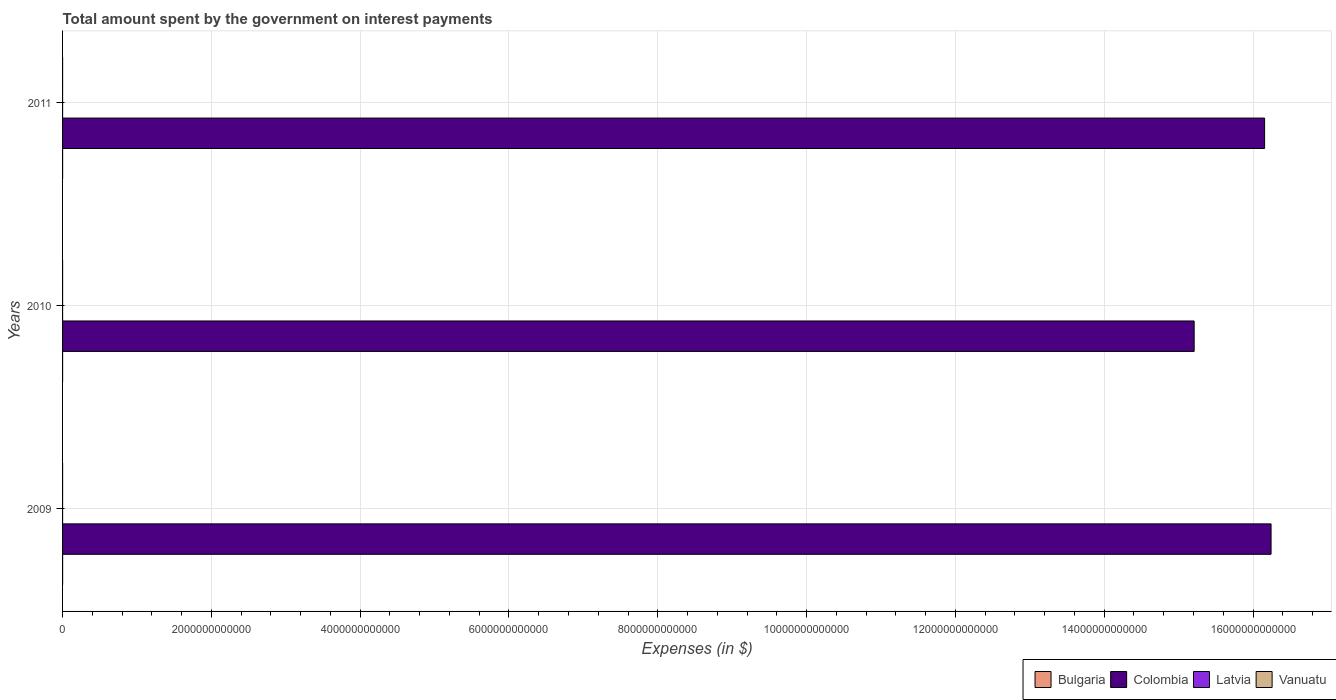Are the number of bars per tick equal to the number of legend labels?
Offer a very short reply. Yes. How many bars are there on the 1st tick from the top?
Keep it short and to the point. 4. How many bars are there on the 3rd tick from the bottom?
Provide a short and direct response. 4. What is the label of the 3rd group of bars from the top?
Ensure brevity in your answer.  2009. What is the amount spent on interest payments by the government in Vanuatu in 2010?
Offer a terse response. 3.34e+08. Across all years, what is the maximum amount spent on interest payments by the government in Latvia?
Offer a terse response. 1.91e+08. Across all years, what is the minimum amount spent on interest payments by the government in Vanuatu?
Provide a succinct answer. 3.18e+08. In which year was the amount spent on interest payments by the government in Bulgaria maximum?
Give a very brief answer. 2011. What is the total amount spent on interest payments by the government in Colombia in the graph?
Your response must be concise. 4.76e+13. What is the difference between the amount spent on interest payments by the government in Bulgaria in 2009 and that in 2010?
Provide a short and direct response. 4.27e+07. What is the difference between the amount spent on interest payments by the government in Latvia in 2010 and the amount spent on interest payments by the government in Colombia in 2011?
Offer a terse response. -1.62e+13. What is the average amount spent on interest payments by the government in Bulgaria per year?
Offer a very short reply. 4.92e+08. In the year 2009, what is the difference between the amount spent on interest payments by the government in Colombia and amount spent on interest payments by the government in Bulgaria?
Offer a terse response. 1.62e+13. What is the ratio of the amount spent on interest payments by the government in Bulgaria in 2010 to that in 2011?
Your answer should be very brief. 0.89. What is the difference between the highest and the second highest amount spent on interest payments by the government in Latvia?
Provide a short and direct response. 2.07e+07. What is the difference between the highest and the lowest amount spent on interest payments by the government in Bulgaria?
Give a very brief answer. 5.47e+07. Is the sum of the amount spent on interest payments by the government in Colombia in 2010 and 2011 greater than the maximum amount spent on interest payments by the government in Bulgaria across all years?
Keep it short and to the point. Yes. What does the 3rd bar from the top in 2009 represents?
Ensure brevity in your answer.  Colombia. What does the 2nd bar from the bottom in 2010 represents?
Your answer should be compact. Colombia. Are all the bars in the graph horizontal?
Ensure brevity in your answer.  Yes. What is the difference between two consecutive major ticks on the X-axis?
Offer a terse response. 2.00e+12. Are the values on the major ticks of X-axis written in scientific E-notation?
Keep it short and to the point. No. Does the graph contain any zero values?
Make the answer very short. No. Where does the legend appear in the graph?
Give a very brief answer. Bottom right. How are the legend labels stacked?
Your answer should be compact. Horizontal. What is the title of the graph?
Make the answer very short. Total amount spent by the government on interest payments. What is the label or title of the X-axis?
Provide a succinct answer. Expenses (in $). What is the label or title of the Y-axis?
Your answer should be compact. Years. What is the Expenses (in $) in Bulgaria in 2009?
Ensure brevity in your answer.  5.03e+08. What is the Expenses (in $) in Colombia in 2009?
Your response must be concise. 1.62e+13. What is the Expenses (in $) of Latvia in 2009?
Make the answer very short. 1.44e+08. What is the Expenses (in $) in Vanuatu in 2009?
Provide a succinct answer. 3.18e+08. What is the Expenses (in $) in Bulgaria in 2010?
Your answer should be compact. 4.60e+08. What is the Expenses (in $) in Colombia in 2010?
Ensure brevity in your answer.  1.52e+13. What is the Expenses (in $) of Latvia in 2010?
Give a very brief answer. 1.70e+08. What is the Expenses (in $) in Vanuatu in 2010?
Your answer should be compact. 3.34e+08. What is the Expenses (in $) of Bulgaria in 2011?
Offer a very short reply. 5.15e+08. What is the Expenses (in $) of Colombia in 2011?
Your answer should be compact. 1.62e+13. What is the Expenses (in $) of Latvia in 2011?
Ensure brevity in your answer.  1.91e+08. What is the Expenses (in $) of Vanuatu in 2011?
Your answer should be very brief. 4.68e+08. Across all years, what is the maximum Expenses (in $) in Bulgaria?
Keep it short and to the point. 5.15e+08. Across all years, what is the maximum Expenses (in $) of Colombia?
Your response must be concise. 1.62e+13. Across all years, what is the maximum Expenses (in $) of Latvia?
Offer a very short reply. 1.91e+08. Across all years, what is the maximum Expenses (in $) in Vanuatu?
Provide a short and direct response. 4.68e+08. Across all years, what is the minimum Expenses (in $) of Bulgaria?
Your answer should be very brief. 4.60e+08. Across all years, what is the minimum Expenses (in $) in Colombia?
Offer a terse response. 1.52e+13. Across all years, what is the minimum Expenses (in $) of Latvia?
Keep it short and to the point. 1.44e+08. Across all years, what is the minimum Expenses (in $) in Vanuatu?
Your answer should be very brief. 3.18e+08. What is the total Expenses (in $) in Bulgaria in the graph?
Offer a very short reply. 1.48e+09. What is the total Expenses (in $) in Colombia in the graph?
Provide a short and direct response. 4.76e+13. What is the total Expenses (in $) of Latvia in the graph?
Give a very brief answer. 5.05e+08. What is the total Expenses (in $) of Vanuatu in the graph?
Offer a terse response. 1.12e+09. What is the difference between the Expenses (in $) of Bulgaria in 2009 and that in 2010?
Your answer should be compact. 4.27e+07. What is the difference between the Expenses (in $) of Colombia in 2009 and that in 2010?
Offer a very short reply. 1.03e+12. What is the difference between the Expenses (in $) in Latvia in 2009 and that in 2010?
Your answer should be very brief. -2.62e+07. What is the difference between the Expenses (in $) of Vanuatu in 2009 and that in 2010?
Give a very brief answer. -1.57e+07. What is the difference between the Expenses (in $) of Bulgaria in 2009 and that in 2011?
Keep it short and to the point. -1.20e+07. What is the difference between the Expenses (in $) in Colombia in 2009 and that in 2011?
Provide a short and direct response. 8.67e+1. What is the difference between the Expenses (in $) in Latvia in 2009 and that in 2011?
Your response must be concise. -4.69e+07. What is the difference between the Expenses (in $) of Vanuatu in 2009 and that in 2011?
Your answer should be very brief. -1.50e+08. What is the difference between the Expenses (in $) of Bulgaria in 2010 and that in 2011?
Offer a terse response. -5.47e+07. What is the difference between the Expenses (in $) of Colombia in 2010 and that in 2011?
Keep it short and to the point. -9.47e+11. What is the difference between the Expenses (in $) of Latvia in 2010 and that in 2011?
Provide a short and direct response. -2.07e+07. What is the difference between the Expenses (in $) of Vanuatu in 2010 and that in 2011?
Offer a terse response. -1.34e+08. What is the difference between the Expenses (in $) in Bulgaria in 2009 and the Expenses (in $) in Colombia in 2010?
Keep it short and to the point. -1.52e+13. What is the difference between the Expenses (in $) of Bulgaria in 2009 and the Expenses (in $) of Latvia in 2010?
Offer a very short reply. 3.32e+08. What is the difference between the Expenses (in $) of Bulgaria in 2009 and the Expenses (in $) of Vanuatu in 2010?
Your answer should be compact. 1.69e+08. What is the difference between the Expenses (in $) of Colombia in 2009 and the Expenses (in $) of Latvia in 2010?
Your response must be concise. 1.62e+13. What is the difference between the Expenses (in $) in Colombia in 2009 and the Expenses (in $) in Vanuatu in 2010?
Provide a succinct answer. 1.62e+13. What is the difference between the Expenses (in $) of Latvia in 2009 and the Expenses (in $) of Vanuatu in 2010?
Provide a succinct answer. -1.89e+08. What is the difference between the Expenses (in $) of Bulgaria in 2009 and the Expenses (in $) of Colombia in 2011?
Your answer should be very brief. -1.62e+13. What is the difference between the Expenses (in $) in Bulgaria in 2009 and the Expenses (in $) in Latvia in 2011?
Your response must be concise. 3.12e+08. What is the difference between the Expenses (in $) in Bulgaria in 2009 and the Expenses (in $) in Vanuatu in 2011?
Your response must be concise. 3.51e+07. What is the difference between the Expenses (in $) of Colombia in 2009 and the Expenses (in $) of Latvia in 2011?
Offer a terse response. 1.62e+13. What is the difference between the Expenses (in $) in Colombia in 2009 and the Expenses (in $) in Vanuatu in 2011?
Your response must be concise. 1.62e+13. What is the difference between the Expenses (in $) in Latvia in 2009 and the Expenses (in $) in Vanuatu in 2011?
Your answer should be very brief. -3.23e+08. What is the difference between the Expenses (in $) in Bulgaria in 2010 and the Expenses (in $) in Colombia in 2011?
Make the answer very short. -1.62e+13. What is the difference between the Expenses (in $) of Bulgaria in 2010 and the Expenses (in $) of Latvia in 2011?
Keep it short and to the point. 2.69e+08. What is the difference between the Expenses (in $) in Bulgaria in 2010 and the Expenses (in $) in Vanuatu in 2011?
Provide a succinct answer. -7.58e+06. What is the difference between the Expenses (in $) of Colombia in 2010 and the Expenses (in $) of Latvia in 2011?
Your answer should be compact. 1.52e+13. What is the difference between the Expenses (in $) in Colombia in 2010 and the Expenses (in $) in Vanuatu in 2011?
Offer a very short reply. 1.52e+13. What is the difference between the Expenses (in $) of Latvia in 2010 and the Expenses (in $) of Vanuatu in 2011?
Offer a very short reply. -2.97e+08. What is the average Expenses (in $) of Bulgaria per year?
Your response must be concise. 4.92e+08. What is the average Expenses (in $) of Colombia per year?
Ensure brevity in your answer.  1.59e+13. What is the average Expenses (in $) in Latvia per year?
Make the answer very short. 1.68e+08. What is the average Expenses (in $) in Vanuatu per year?
Provide a short and direct response. 3.73e+08. In the year 2009, what is the difference between the Expenses (in $) in Bulgaria and Expenses (in $) in Colombia?
Make the answer very short. -1.62e+13. In the year 2009, what is the difference between the Expenses (in $) in Bulgaria and Expenses (in $) in Latvia?
Offer a very short reply. 3.59e+08. In the year 2009, what is the difference between the Expenses (in $) of Bulgaria and Expenses (in $) of Vanuatu?
Provide a succinct answer. 1.85e+08. In the year 2009, what is the difference between the Expenses (in $) in Colombia and Expenses (in $) in Latvia?
Offer a terse response. 1.62e+13. In the year 2009, what is the difference between the Expenses (in $) of Colombia and Expenses (in $) of Vanuatu?
Make the answer very short. 1.62e+13. In the year 2009, what is the difference between the Expenses (in $) in Latvia and Expenses (in $) in Vanuatu?
Give a very brief answer. -1.74e+08. In the year 2010, what is the difference between the Expenses (in $) of Bulgaria and Expenses (in $) of Colombia?
Keep it short and to the point. -1.52e+13. In the year 2010, what is the difference between the Expenses (in $) in Bulgaria and Expenses (in $) in Latvia?
Offer a terse response. 2.90e+08. In the year 2010, what is the difference between the Expenses (in $) in Bulgaria and Expenses (in $) in Vanuatu?
Keep it short and to the point. 1.26e+08. In the year 2010, what is the difference between the Expenses (in $) in Colombia and Expenses (in $) in Latvia?
Your answer should be compact. 1.52e+13. In the year 2010, what is the difference between the Expenses (in $) in Colombia and Expenses (in $) in Vanuatu?
Provide a short and direct response. 1.52e+13. In the year 2010, what is the difference between the Expenses (in $) in Latvia and Expenses (in $) in Vanuatu?
Ensure brevity in your answer.  -1.63e+08. In the year 2011, what is the difference between the Expenses (in $) of Bulgaria and Expenses (in $) of Colombia?
Provide a succinct answer. -1.62e+13. In the year 2011, what is the difference between the Expenses (in $) of Bulgaria and Expenses (in $) of Latvia?
Provide a succinct answer. 3.24e+08. In the year 2011, what is the difference between the Expenses (in $) in Bulgaria and Expenses (in $) in Vanuatu?
Ensure brevity in your answer.  4.71e+07. In the year 2011, what is the difference between the Expenses (in $) in Colombia and Expenses (in $) in Latvia?
Offer a very short reply. 1.62e+13. In the year 2011, what is the difference between the Expenses (in $) in Colombia and Expenses (in $) in Vanuatu?
Keep it short and to the point. 1.62e+13. In the year 2011, what is the difference between the Expenses (in $) of Latvia and Expenses (in $) of Vanuatu?
Provide a succinct answer. -2.77e+08. What is the ratio of the Expenses (in $) of Bulgaria in 2009 to that in 2010?
Make the answer very short. 1.09. What is the ratio of the Expenses (in $) of Colombia in 2009 to that in 2010?
Give a very brief answer. 1.07. What is the ratio of the Expenses (in $) in Latvia in 2009 to that in 2010?
Provide a succinct answer. 0.85. What is the ratio of the Expenses (in $) in Vanuatu in 2009 to that in 2010?
Keep it short and to the point. 0.95. What is the ratio of the Expenses (in $) of Bulgaria in 2009 to that in 2011?
Provide a succinct answer. 0.98. What is the ratio of the Expenses (in $) in Colombia in 2009 to that in 2011?
Offer a very short reply. 1.01. What is the ratio of the Expenses (in $) of Latvia in 2009 to that in 2011?
Provide a succinct answer. 0.75. What is the ratio of the Expenses (in $) of Vanuatu in 2009 to that in 2011?
Keep it short and to the point. 0.68. What is the ratio of the Expenses (in $) of Bulgaria in 2010 to that in 2011?
Provide a short and direct response. 0.89. What is the ratio of the Expenses (in $) in Colombia in 2010 to that in 2011?
Offer a terse response. 0.94. What is the ratio of the Expenses (in $) of Latvia in 2010 to that in 2011?
Make the answer very short. 0.89. What is the ratio of the Expenses (in $) of Vanuatu in 2010 to that in 2011?
Your answer should be compact. 0.71. What is the difference between the highest and the second highest Expenses (in $) of Bulgaria?
Offer a terse response. 1.20e+07. What is the difference between the highest and the second highest Expenses (in $) in Colombia?
Give a very brief answer. 8.67e+1. What is the difference between the highest and the second highest Expenses (in $) of Latvia?
Give a very brief answer. 2.07e+07. What is the difference between the highest and the second highest Expenses (in $) in Vanuatu?
Make the answer very short. 1.34e+08. What is the difference between the highest and the lowest Expenses (in $) of Bulgaria?
Your response must be concise. 5.47e+07. What is the difference between the highest and the lowest Expenses (in $) of Colombia?
Give a very brief answer. 1.03e+12. What is the difference between the highest and the lowest Expenses (in $) of Latvia?
Your answer should be very brief. 4.69e+07. What is the difference between the highest and the lowest Expenses (in $) in Vanuatu?
Provide a short and direct response. 1.50e+08. 